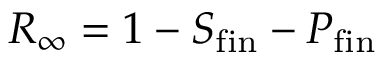Convert formula to latex. <formula><loc_0><loc_0><loc_500><loc_500>R _ { \infty } = 1 - S _ { f i n } - P _ { f i n }</formula> 